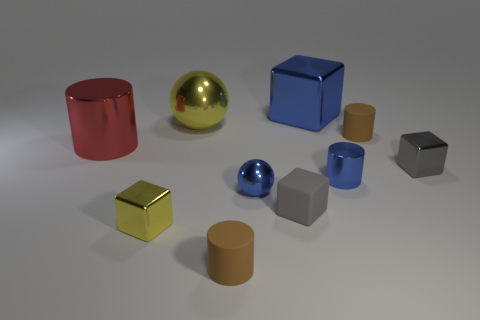Subtract all cylinders. How many objects are left? 6 Add 7 blue shiny blocks. How many blue shiny blocks are left? 8 Add 8 tiny blue metal balls. How many tiny blue metal balls exist? 9 Subtract 0 purple blocks. How many objects are left? 10 Subtract all small blocks. Subtract all large metal spheres. How many objects are left? 6 